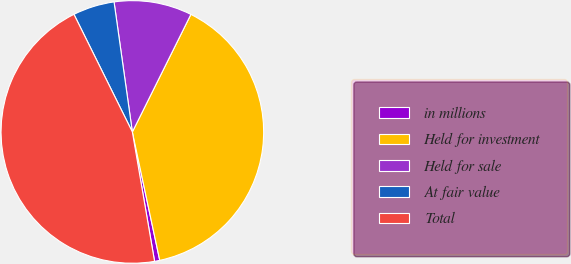Convert chart to OTSL. <chart><loc_0><loc_0><loc_500><loc_500><pie_chart><fcel>in millions<fcel>Held for investment<fcel>Held for sale<fcel>At fair value<fcel>Total<nl><fcel>0.64%<fcel>39.3%<fcel>9.58%<fcel>5.11%<fcel>45.37%<nl></chart> 